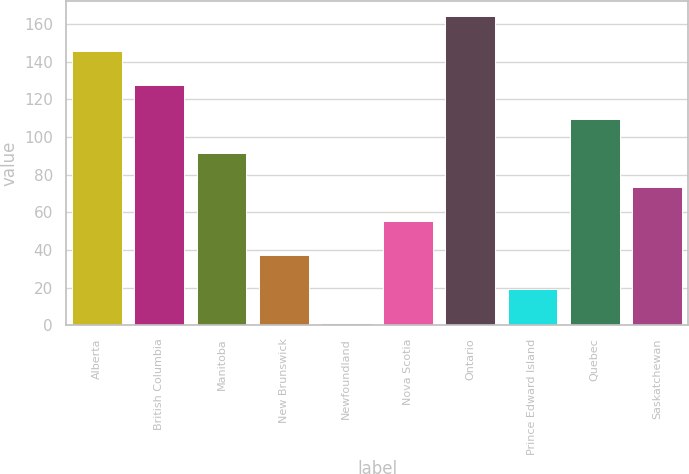Convert chart. <chart><loc_0><loc_0><loc_500><loc_500><bar_chart><fcel>Alberta<fcel>British Columbia<fcel>Manitoba<fcel>New Brunswick<fcel>Newfoundland<fcel>Nova Scotia<fcel>Ontario<fcel>Prince Edward Island<fcel>Quebec<fcel>Saskatchewan<nl><fcel>145.8<fcel>127.7<fcel>91.5<fcel>37.2<fcel>1<fcel>55.3<fcel>163.9<fcel>19.1<fcel>109.6<fcel>73.4<nl></chart> 